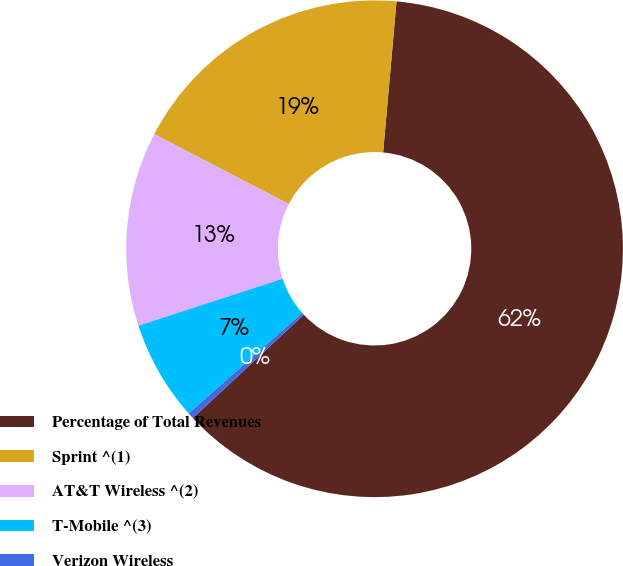<chart> <loc_0><loc_0><loc_500><loc_500><pie_chart><fcel>Percentage of Total Revenues<fcel>Sprint ^(1)<fcel>AT&T Wireless ^(2)<fcel>T-Mobile ^(3)<fcel>Verizon Wireless<nl><fcel>61.65%<fcel>18.77%<fcel>12.65%<fcel>6.52%<fcel>0.4%<nl></chart> 